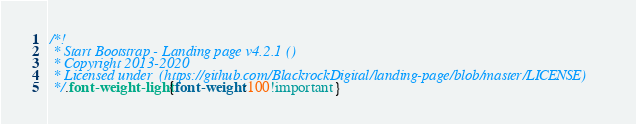<code> <loc_0><loc_0><loc_500><loc_500><_CSS_>/*!
 * Start Bootstrap - Landing page v4.2.1 ()
 * Copyright 2013-2020 
 * Licensed under  (https://github.com/BlackrockDigital/landing-page/blob/master/LICENSE)
 */.font-weight-light{font-weight:100!important}</code> 